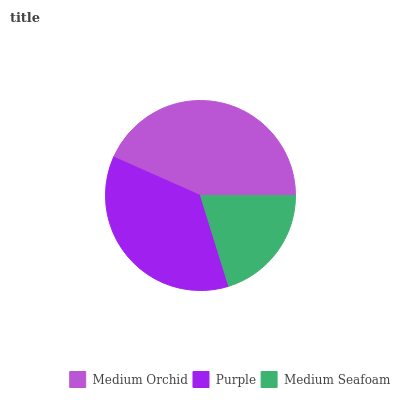Is Medium Seafoam the minimum?
Answer yes or no. Yes. Is Medium Orchid the maximum?
Answer yes or no. Yes. Is Purple the minimum?
Answer yes or no. No. Is Purple the maximum?
Answer yes or no. No. Is Medium Orchid greater than Purple?
Answer yes or no. Yes. Is Purple less than Medium Orchid?
Answer yes or no. Yes. Is Purple greater than Medium Orchid?
Answer yes or no. No. Is Medium Orchid less than Purple?
Answer yes or no. No. Is Purple the high median?
Answer yes or no. Yes. Is Purple the low median?
Answer yes or no. Yes. Is Medium Seafoam the high median?
Answer yes or no. No. Is Medium Orchid the low median?
Answer yes or no. No. 